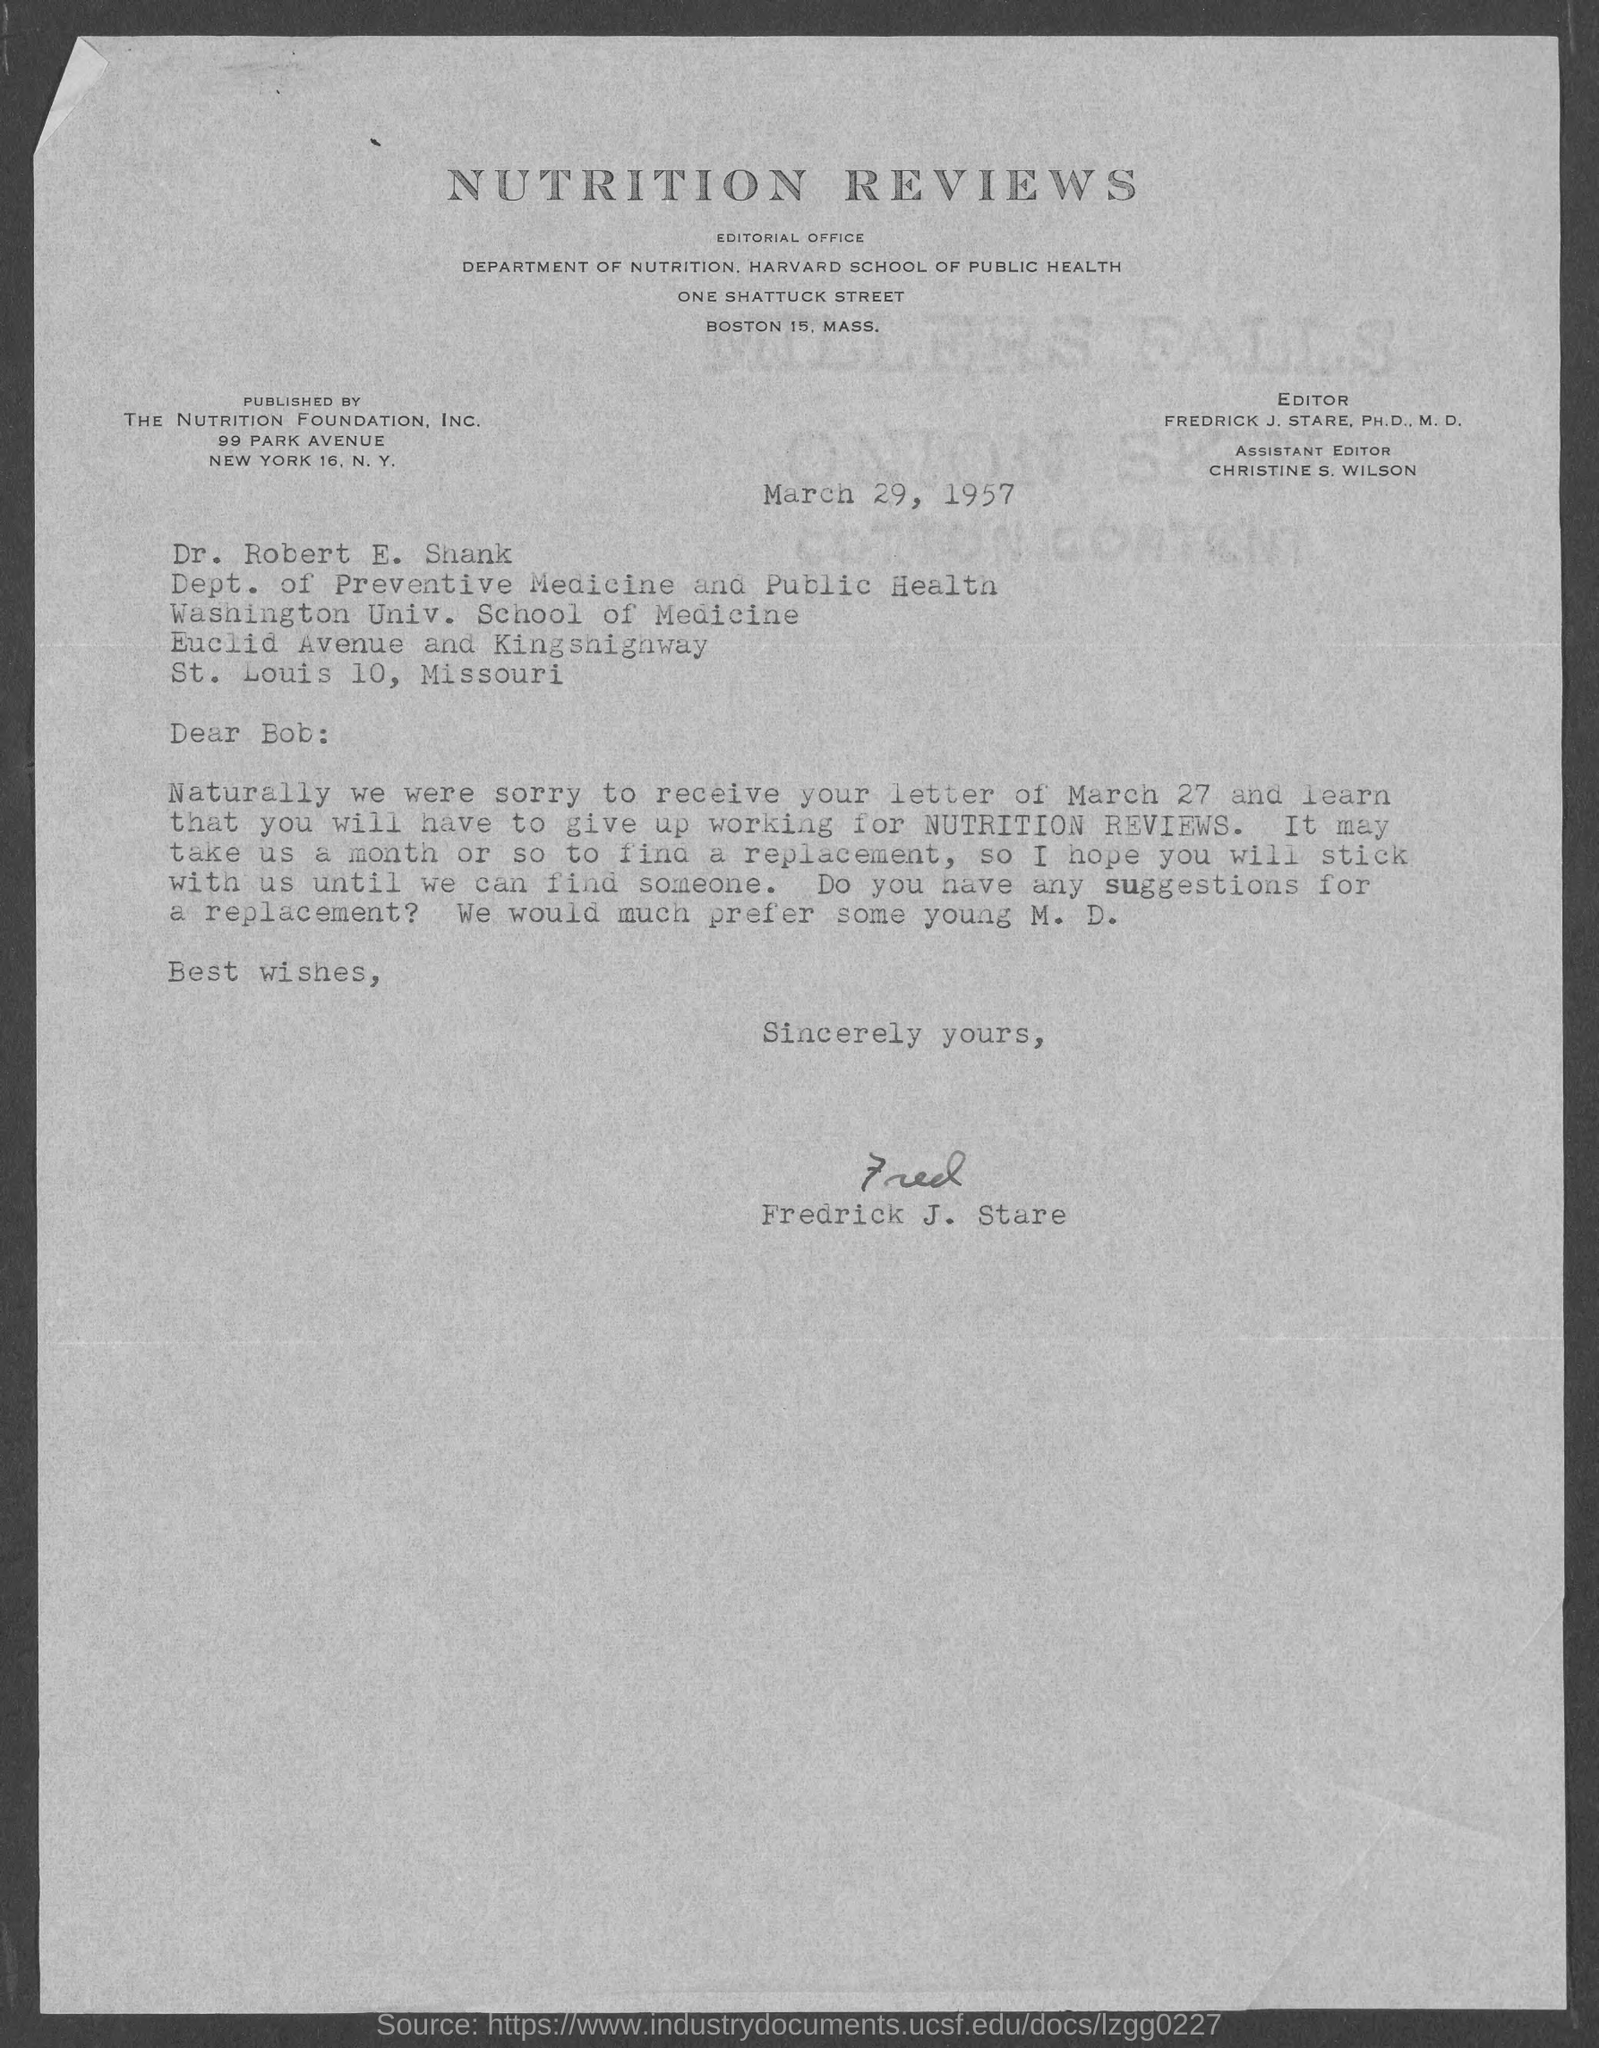What is the date mentioned ?
Provide a succinct answer. MArch 29, 1957. Who is the editor of nutrition reviews?
Offer a terse response. Fredrick J. Stare. Who is the assistant Editor ?
Give a very brief answer. Christine S. Wilson. To whom this letter is written
Your response must be concise. Bob. To which department Dr. Robert E. Shank Belongs to ?
Your response must be concise. Dept. of Preventive medicine and public health. This letter is written by whom ?
Offer a terse response. Fredrick J. Stare. This letter is published by whom ?
Make the answer very short. The Nutrition Foundation, Inc. 